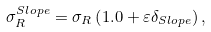<formula> <loc_0><loc_0><loc_500><loc_500>\sigma _ { R } ^ { S l o p e } = \sigma _ { R } \left ( 1 . 0 + \varepsilon \delta _ { S l o p e } \right ) ,</formula> 